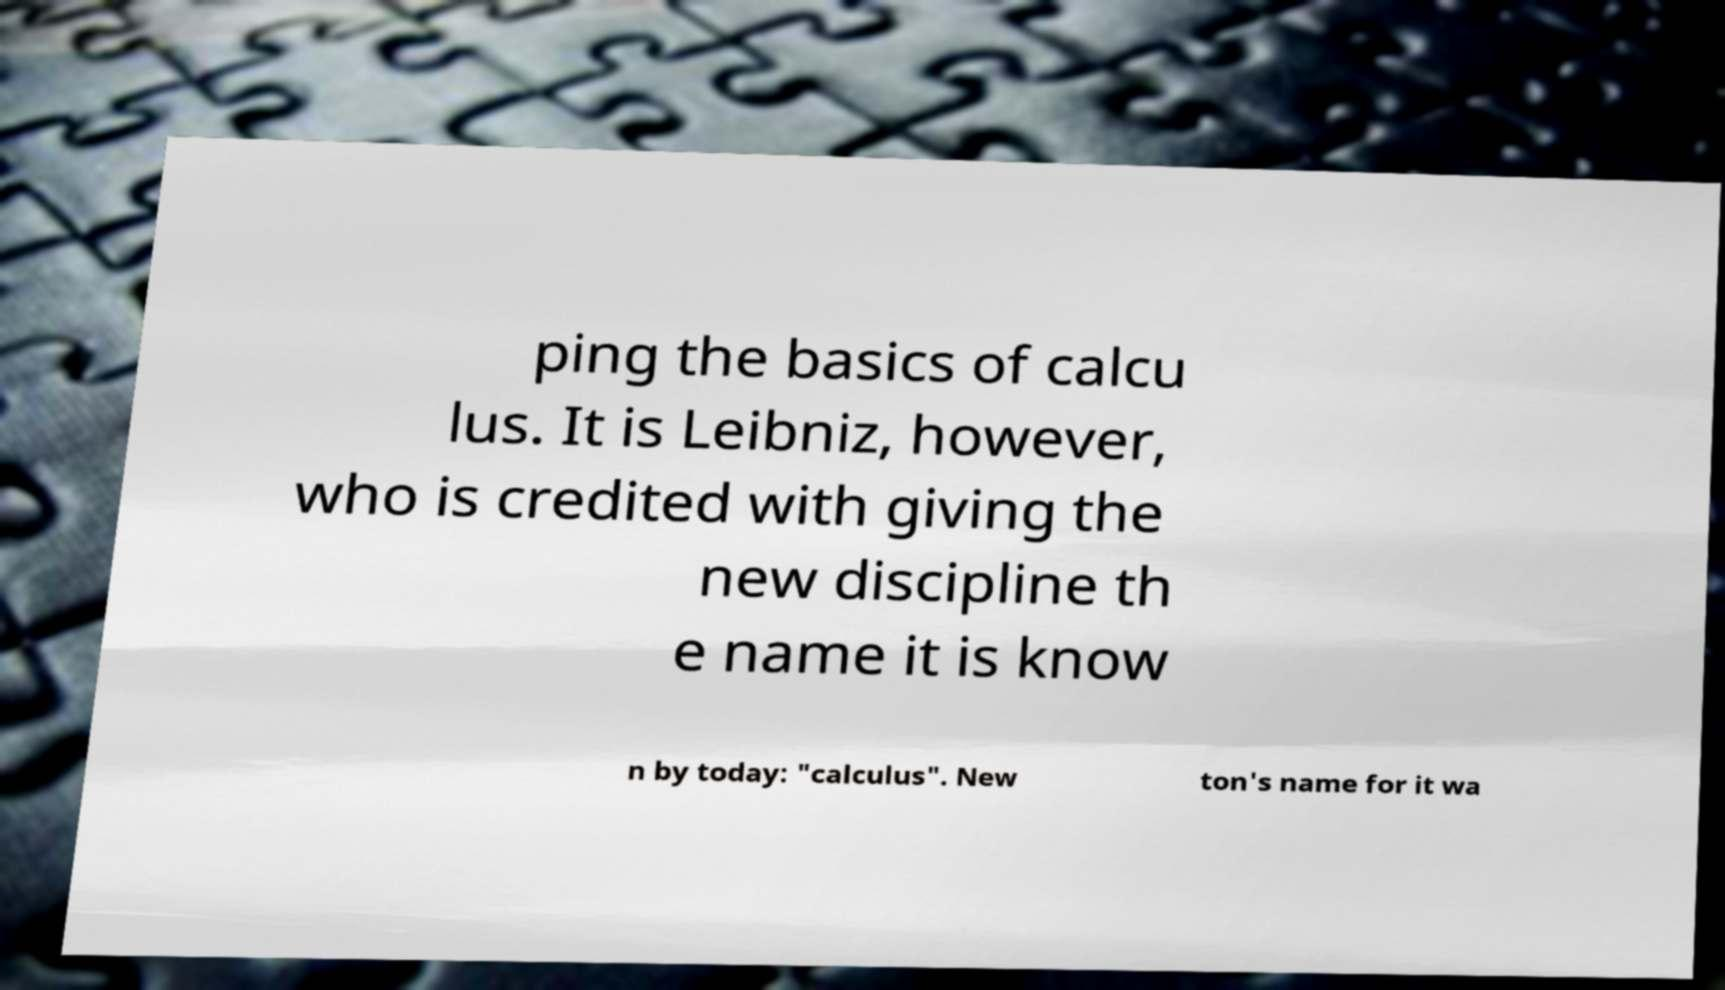There's text embedded in this image that I need extracted. Can you transcribe it verbatim? ping the basics of calcu lus. It is Leibniz, however, who is credited with giving the new discipline th e name it is know n by today: "calculus". New ton's name for it wa 